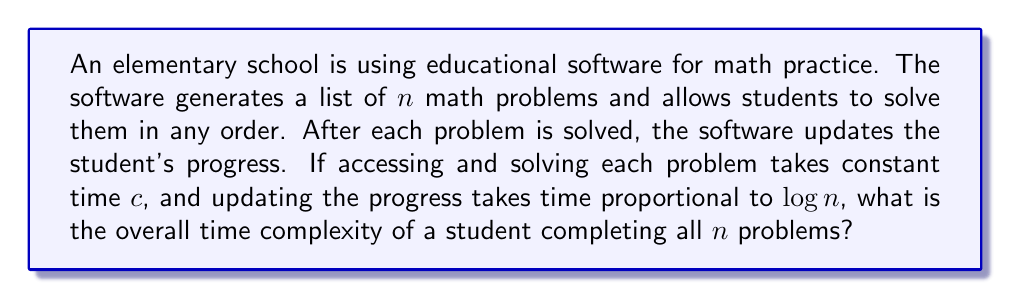Can you answer this question? Let's analyze this step-by-step:

1) For each problem:
   - Accessing and solving: Constant time $c$
   - Updating progress: $O(\log n)$ time

2) This process is repeated for all $n$ problems.

3) So, for each problem, the time taken is:
   $T(1) = c + O(\log n)$

4) For all $n$ problems, the total time is:
   $T(n) = n \cdot (c + O(\log n))$
   
5) Expanding this:
   $T(n) = nc + n \cdot O(\log n)$

6) Simplify:
   $T(n) = O(n) + O(n \log n)$

7) In Big O notation, we keep the term that grows faster. Between $n$ and $n \log n$, $n \log n$ grows faster.

Therefore, the overall time complexity is $O(n \log n)$.

This analysis is relevant for an elementary school principal as it helps in understanding the scalability of the software as the number of problems increases. It shows that the software's performance degrades slightly worse than linearly, which could impact its usability for very large problem sets.
Answer: $O(n \log n)$ 